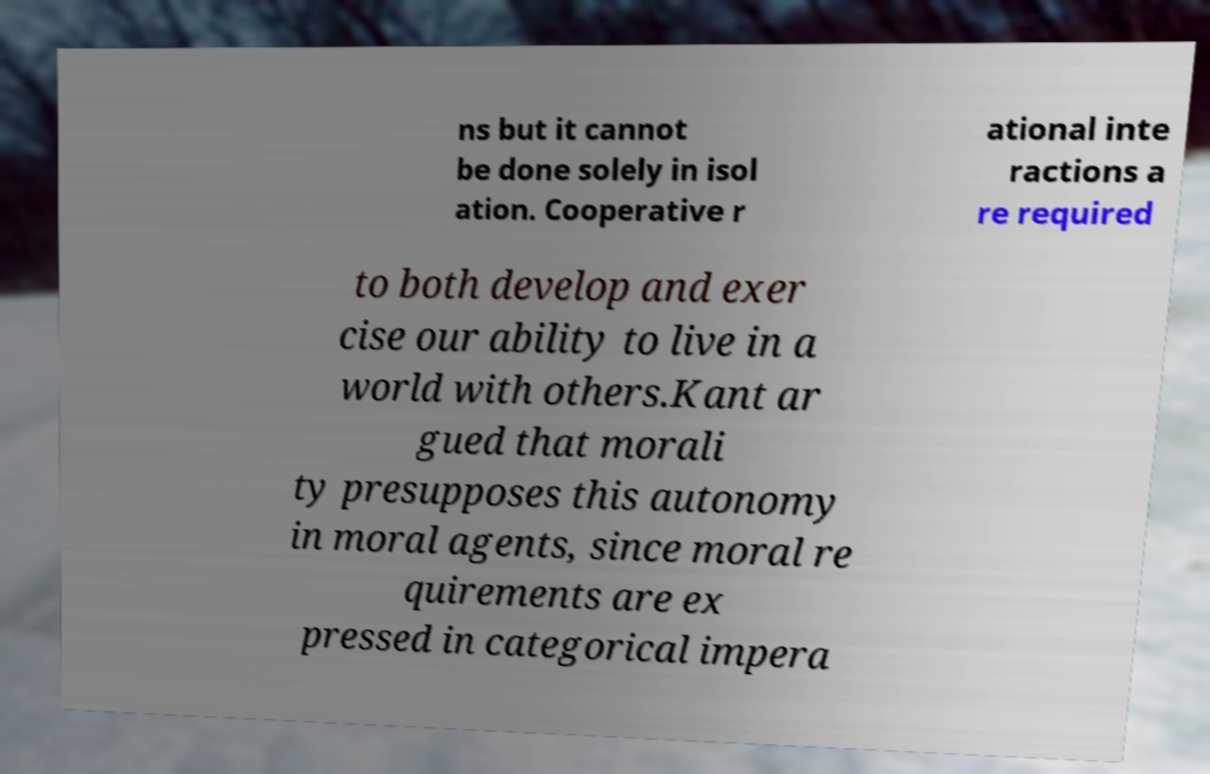Please read and relay the text visible in this image. What does it say? ns but it cannot be done solely in isol ation. Cooperative r ational inte ractions a re required to both develop and exer cise our ability to live in a world with others.Kant ar gued that morali ty presupposes this autonomy in moral agents, since moral re quirements are ex pressed in categorical impera 